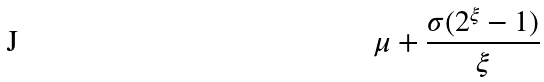Convert formula to latex. <formula><loc_0><loc_0><loc_500><loc_500>\mu + \frac { \sigma ( 2 ^ { \xi } - 1 ) } { \xi }</formula> 